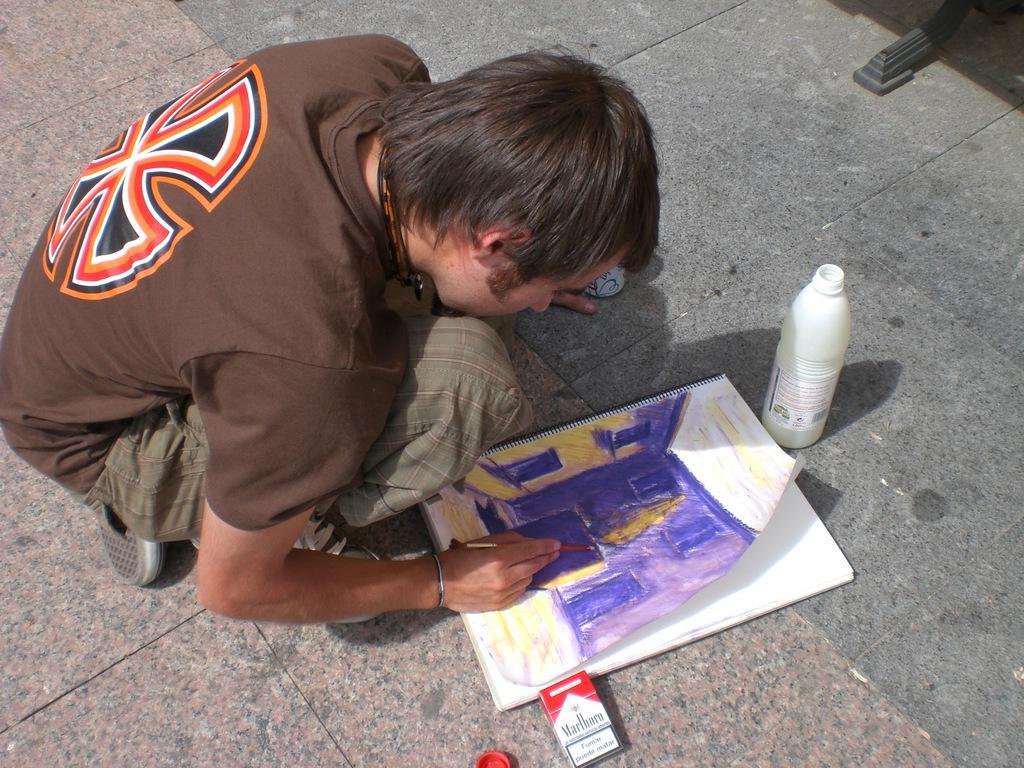How would you summarize this image in a sentence or two? In this image I can see a man is sitting on the ground and I can see he is holding a brush. I can also see he is wearing brown colour t shirt, pant and shoes. On the ground I can see a painting book, white colour bottle, a box, a red colour bottle's cap and on the book I can see a painting. On the top right side of this image I can see a black colour thing. 